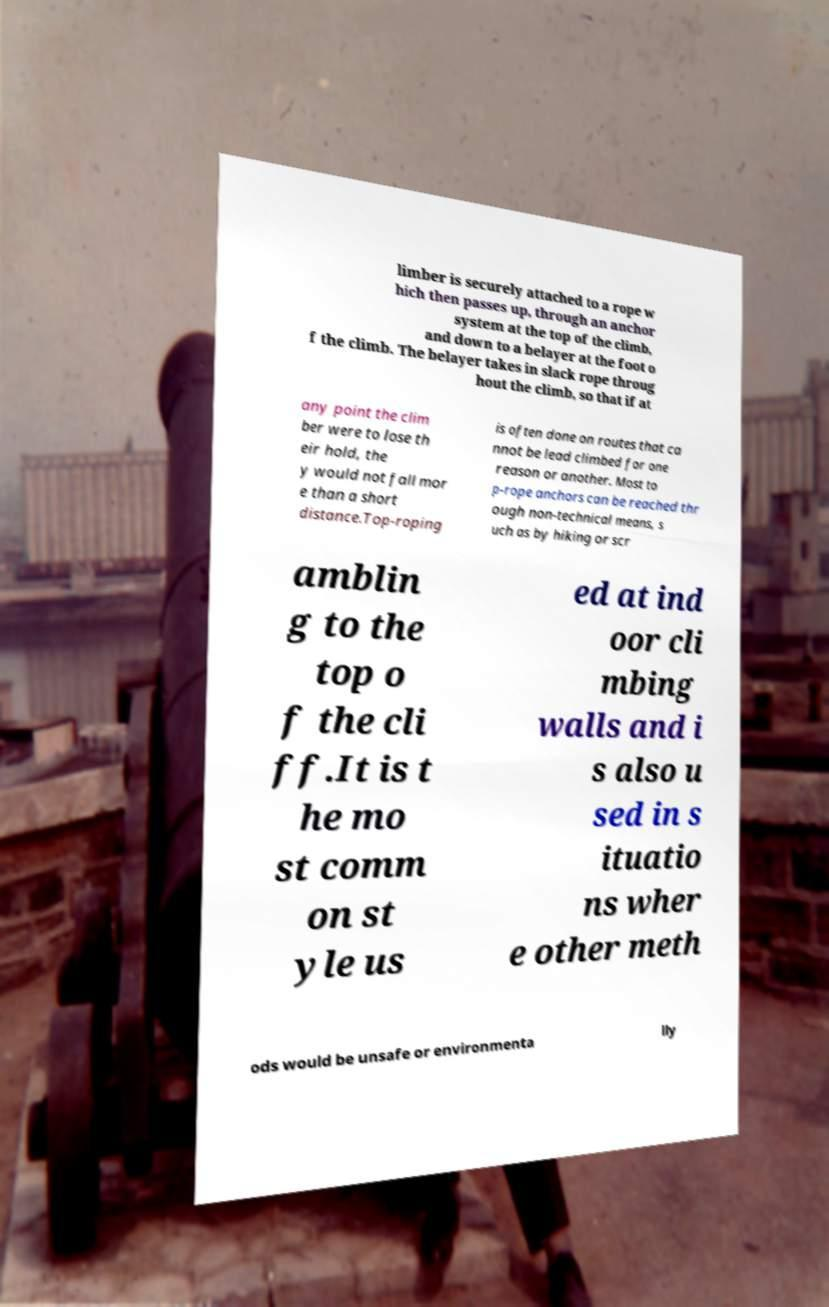For documentation purposes, I need the text within this image transcribed. Could you provide that? limber is securely attached to a rope w hich then passes up, through an anchor system at the top of the climb, and down to a belayer at the foot o f the climb. The belayer takes in slack rope throug hout the climb, so that if at any point the clim ber were to lose th eir hold, the y would not fall mor e than a short distance.Top-roping is often done on routes that ca nnot be lead climbed for one reason or another. Most to p-rope anchors can be reached thr ough non-technical means, s uch as by hiking or scr amblin g to the top o f the cli ff.It is t he mo st comm on st yle us ed at ind oor cli mbing walls and i s also u sed in s ituatio ns wher e other meth ods would be unsafe or environmenta lly 